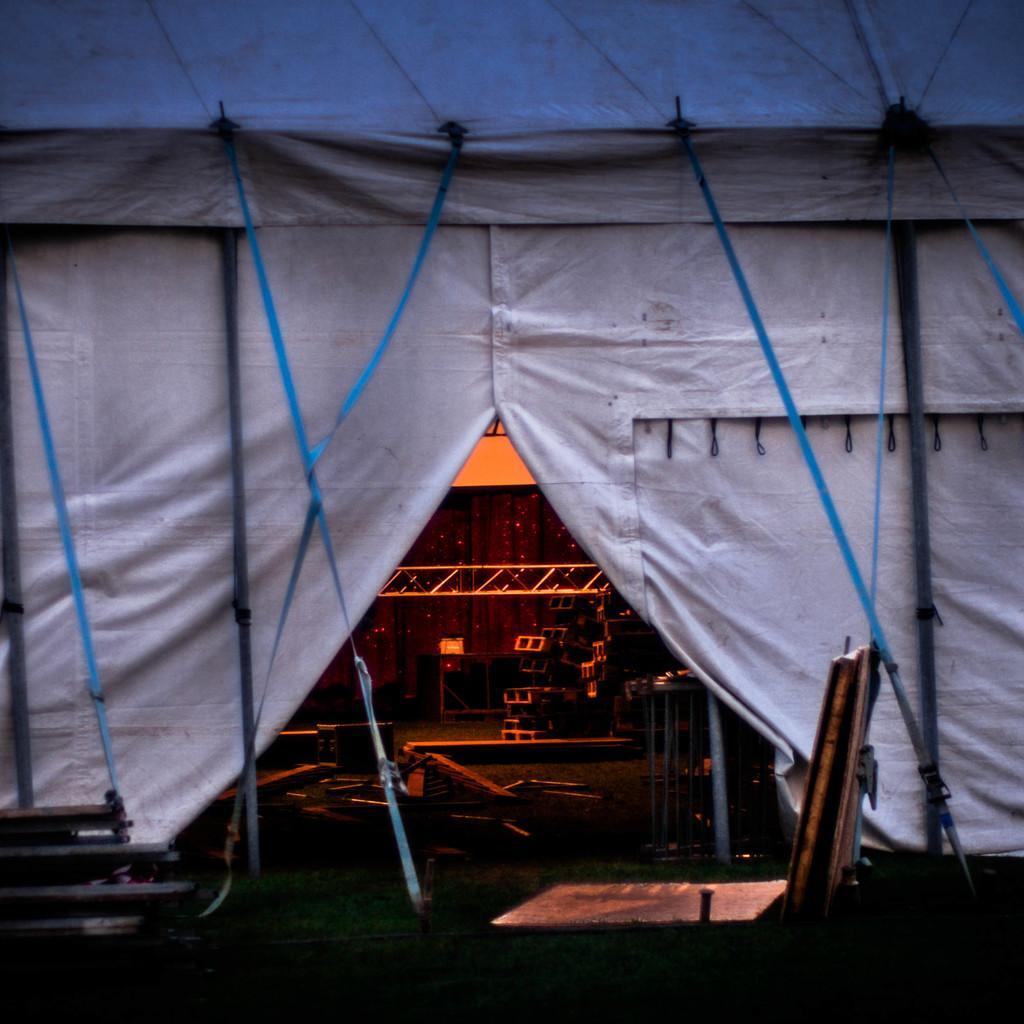Can you describe this image briefly? This image contains a tent. Inside the tent there are few objects on the floor. Bottom of the image there are few objects on the grassland. 